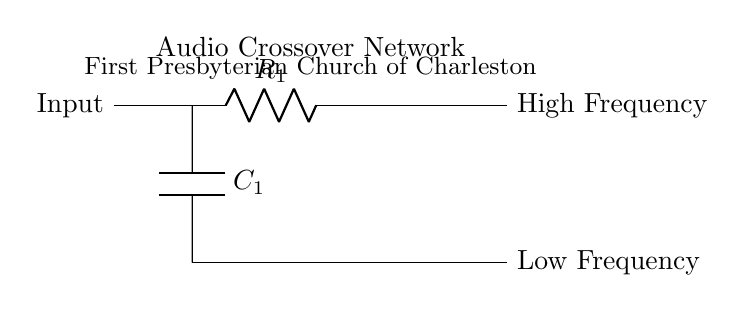What are the two components in this circuit? The circuit contains a resistor labeled R1 and a capacitor labeled C1. The visual representation makes it clear that these two are the primary elements depicted.
Answer: R1, C1 What type of circuit is this? This is an audio crossover network, which typically involves filtering frequencies. The circuit’s structure and labeling indicate it’s designed for separating high and low frequencies.
Answer: Audio crossover network What frequency range does R1 handle? R1 is connected to the high frequency part of the circuit, which is indicated by the label on the right side. The output on this path suggests it channels higher frequency signals.
Answer: High Frequency What frequency range does C1 handle? C1 is connected to the low frequency part of the circuit, as indicated by the corresponding label at the output. This shows that it allows lower frequency signals to pass through.
Answer: Low Frequency What is the relationship between R1 and C1 in this circuit? R1 and C1 work together in a configuration that allows the circuit to filter signals. R1 allows high-frequency signals while C1 allows low-frequency signals, highlighting their cooperative roles in this audio application.
Answer: Filtering frequencies How many nodes are visible in this circuit? A node is a point where two or more circuit elements are connected, and in the diagram, there are three distinct nodes where connections occur.
Answer: Three 